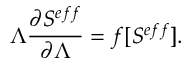Convert formula to latex. <formula><loc_0><loc_0><loc_500><loc_500>\Lambda \frac { \partial S ^ { e f f } } { \partial \Lambda } = f [ S ^ { e f f } ] .</formula> 